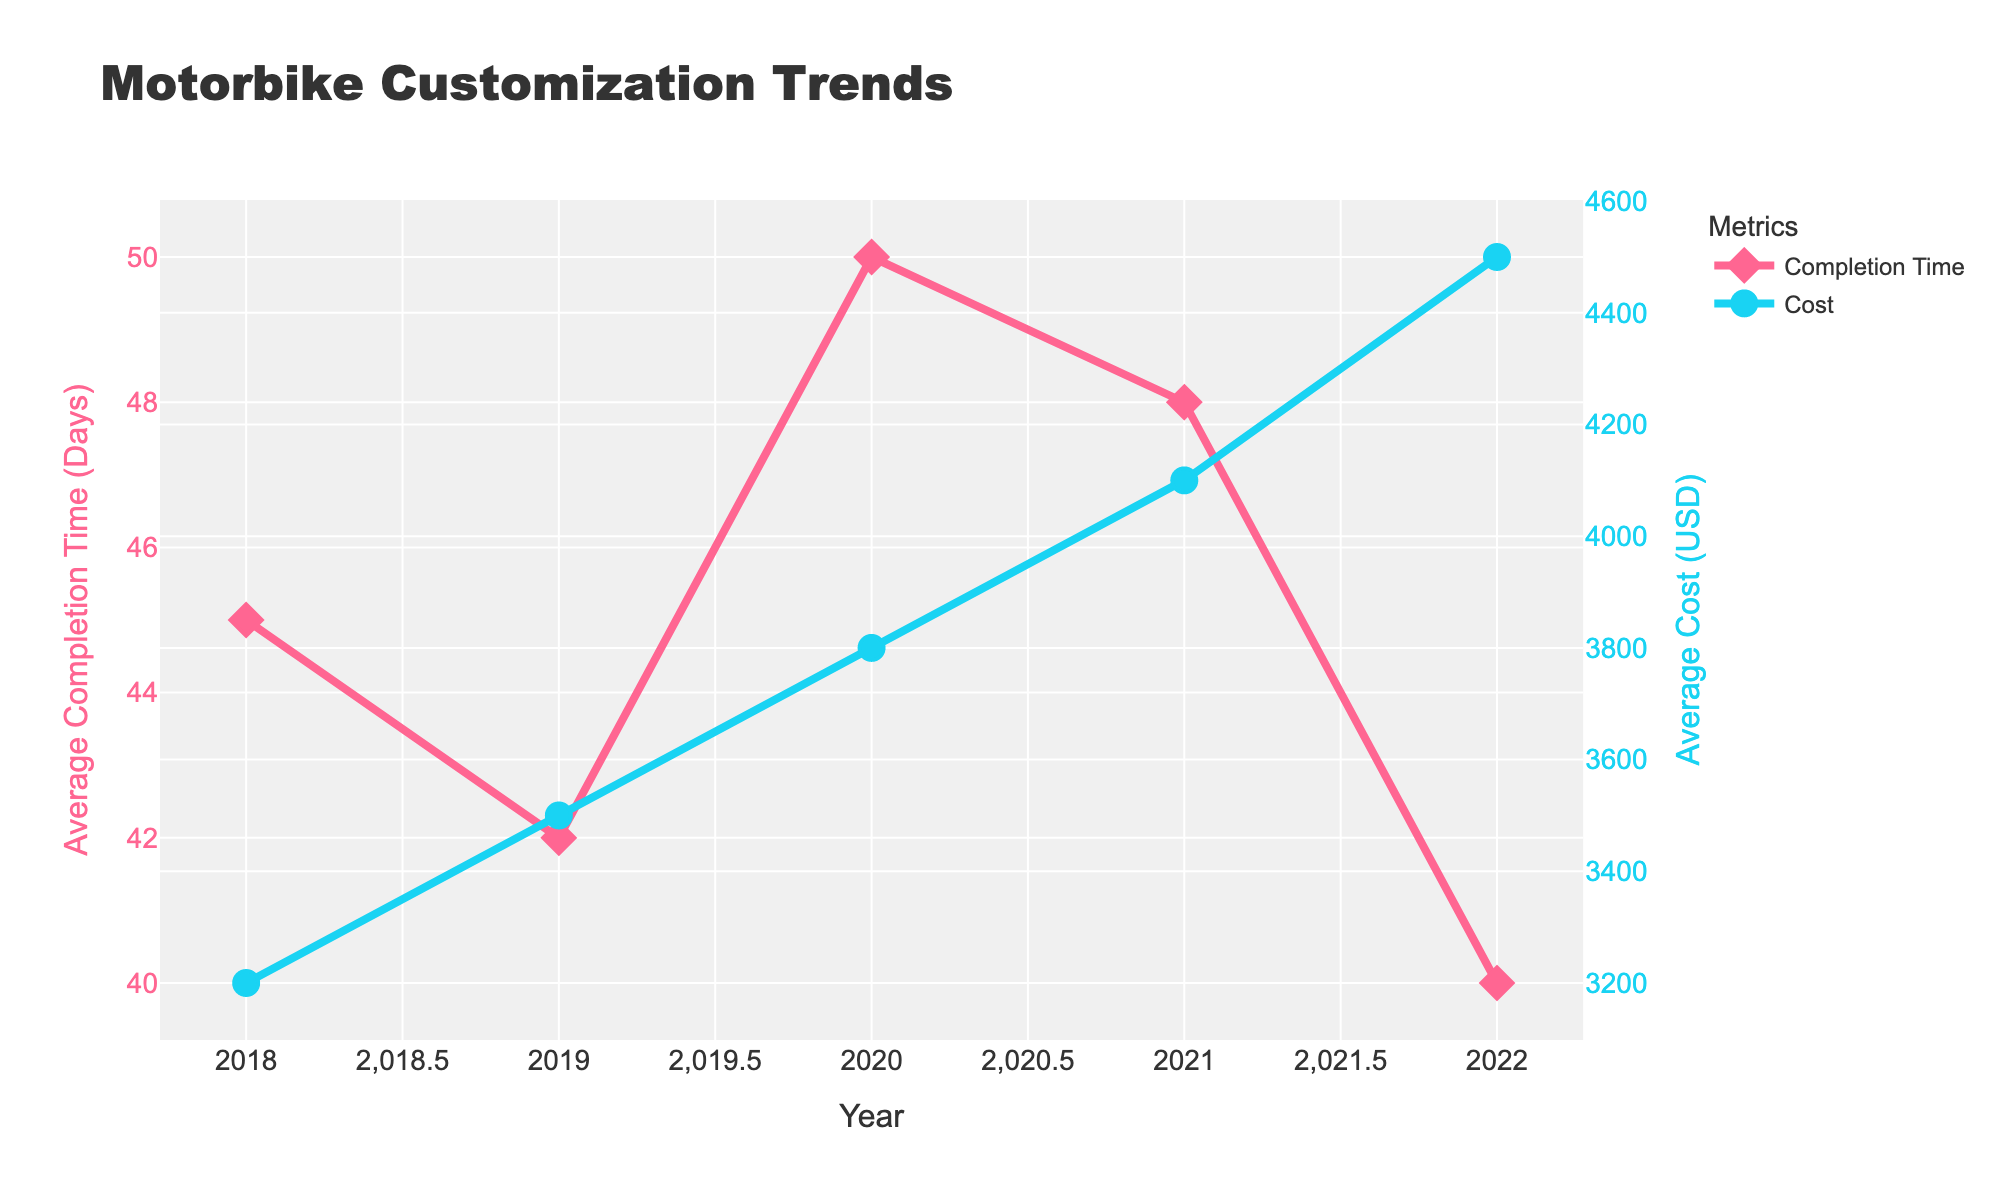What year had the highest average completion time? By observing the line representing the average completion time, the peak occurs in the year with the highest value. 2020 has the highest average completion time, reaching 50 days.
Answer: 2020 What year experienced both the lowest average completion time and the highest average cost? Comparing both lines, the year with the lowest completion time and the highest cost is the one where both respective values are at their extremes. The lowest average completion time is 40 days in 2022, and this year also has the highest average cost of $4500.
Answer: 2022 How does the average completion time in 2019 compare to 2021? By looking at the data points for 2019 and 2021 on the average completion time line, 2019 has 42 days, and 2021 has 48 days. 48 is greater than 42, so the average completion time in 2019 is less than in 2021.
Answer: 42 days in 2019 is less than 48 days in 2021 By how many days did the average completion time decrease from 2021 to 2022? The average completion time in 2021 was 48 days and in 2022 it was 40 days. Subtract 40 from 48 to find the decrease. 48 - 40 = 8
Answer: 8 days What is the total increase in average cost from 2018 to 2022? Starting at $3200 in 2018 and increasing to $4500 in 2022, subtract the initial value from the final value: 4500 - 3200 = 1300
Answer: $1300 Which year had the smallest change in average completion time compared to the previous year? Observing the line for average completion times, compare the year-over-year differences: from 2018 to 2019 it decreased by 3 days, from 2019 to 2020 it increased by 8 days, from 2020 to 2021 it decreased by 2 days, and from 2021 to 2022 it decreased by 8 days. The smallest change is 2 days between 2020 to 2021.
Answer: Between 2020 and 2021 What are the trends in average cost over the five years shown? Looking at the line for average cost, it consistently increases each year from 2018 to 2022, going from $3200 to $4500.
Answer: Increasing trend Compare the visual difference between the markers used for the completion time and cost lines. The markers differ in shape and color: completion time markers are pink diamonds, while cost markers are blue circles. The differences are visible in both shape (diamond vs. circle) and color (pink vs. blue).
Answer: Pink diamonds for completion time, blue circles for cost 